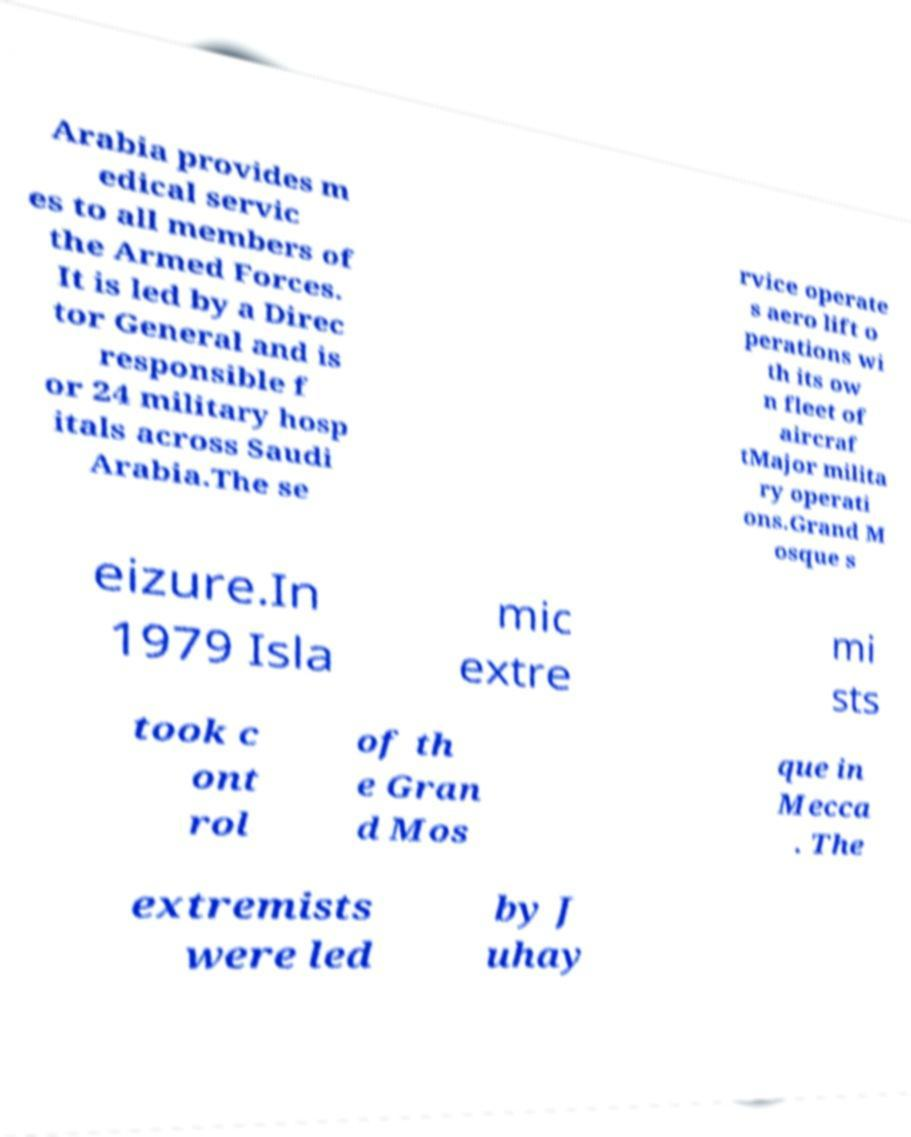What messages or text are displayed in this image? I need them in a readable, typed format. Arabia provides m edical servic es to all members of the Armed Forces. It is led by a Direc tor General and is responsible f or 24 military hosp itals across Saudi Arabia.The se rvice operate s aero lift o perations wi th its ow n fleet of aircraf tMajor milita ry operati ons.Grand M osque s eizure.In 1979 Isla mic extre mi sts took c ont rol of th e Gran d Mos que in Mecca . The extremists were led by J uhay 